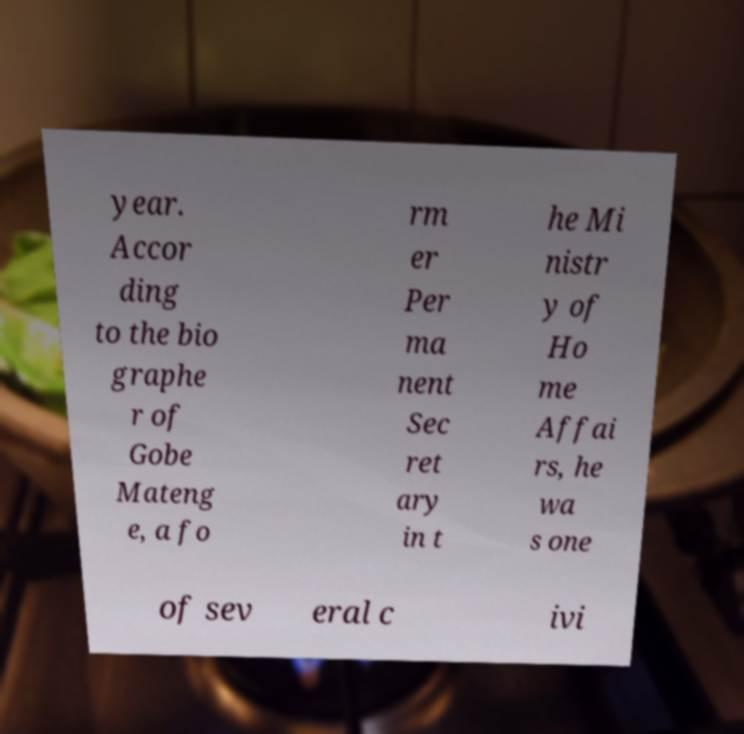For documentation purposes, I need the text within this image transcribed. Could you provide that? year. Accor ding to the bio graphe r of Gobe Mateng e, a fo rm er Per ma nent Sec ret ary in t he Mi nistr y of Ho me Affai rs, he wa s one of sev eral c ivi 